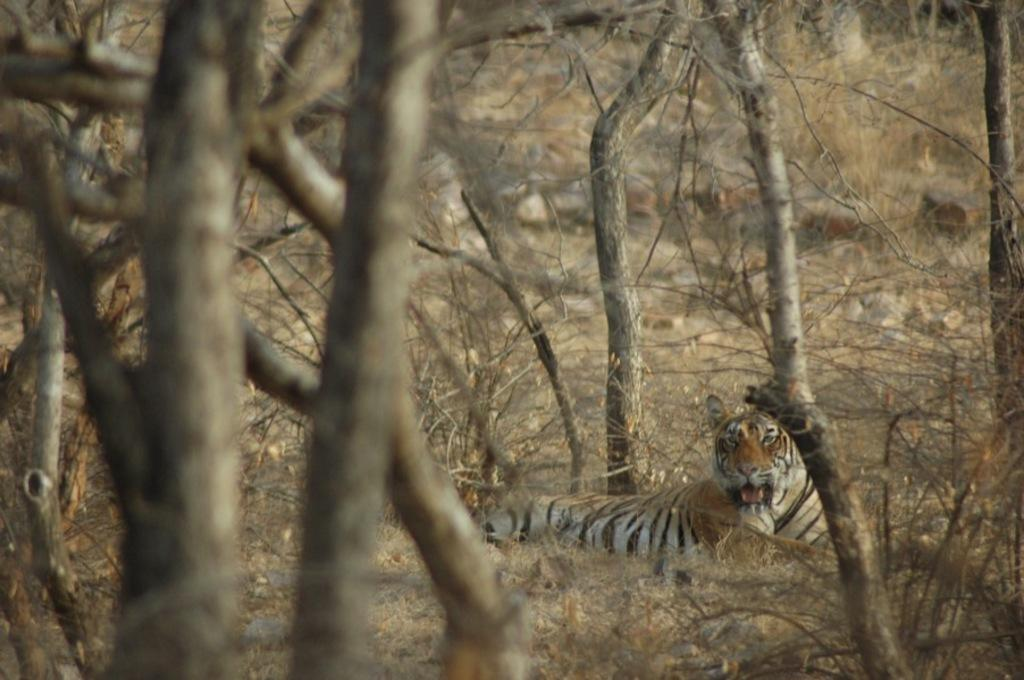What is located in the center of the image? There are trees and a tiger in the center of the image. Can you describe the background of the image? The background of the image is blurred. What type of cabbage is being held by the tiger in the image? There is no cabbage present in the image, and the tiger is not holding anything. 